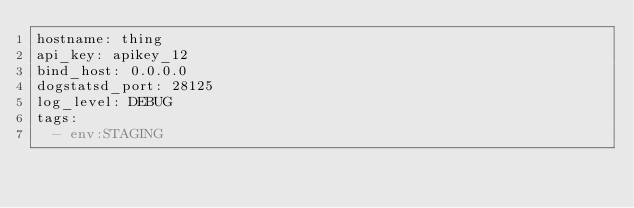<code> <loc_0><loc_0><loc_500><loc_500><_YAML_>hostname: thing
api_key: apikey_12
bind_host: 0.0.0.0
dogstatsd_port: 28125
log_level: DEBUG
tags:
  - env:STAGING
</code> 